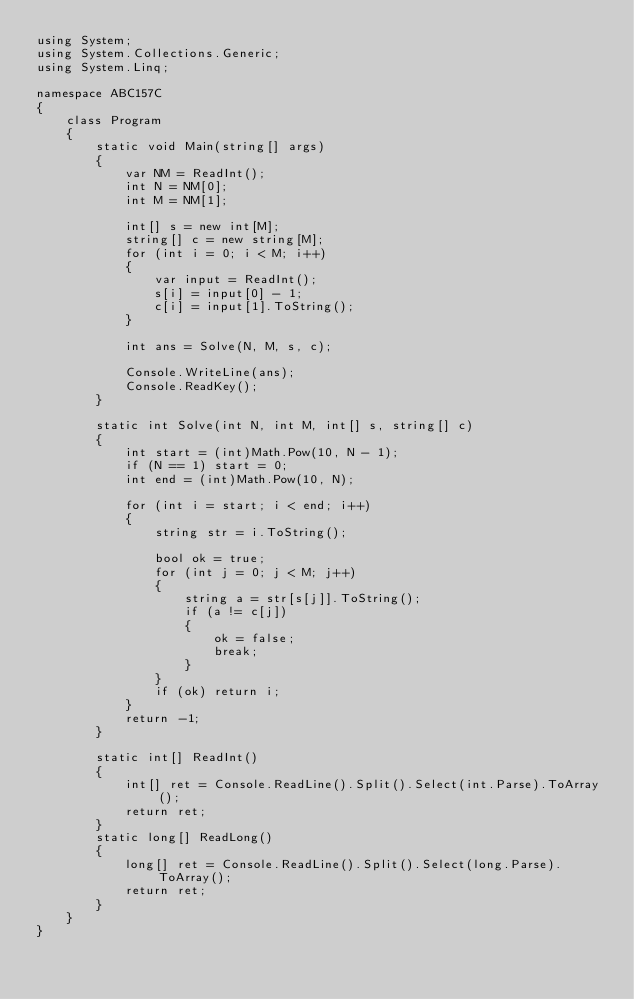Convert code to text. <code><loc_0><loc_0><loc_500><loc_500><_C#_>using System;
using System.Collections.Generic;
using System.Linq;

namespace ABC157C
{
    class Program
    {
        static void Main(string[] args)
        {
            var NM = ReadInt();
            int N = NM[0];
            int M = NM[1];

            int[] s = new int[M];
            string[] c = new string[M];
            for (int i = 0; i < M; i++)
            {
                var input = ReadInt();
                s[i] = input[0] - 1;
                c[i] = input[1].ToString();
            }

            int ans = Solve(N, M, s, c);

            Console.WriteLine(ans);
            Console.ReadKey();
        }

        static int Solve(int N, int M, int[] s, string[] c)
        {
            int start = (int)Math.Pow(10, N - 1);
            if (N == 1) start = 0;
            int end = (int)Math.Pow(10, N);

            for (int i = start; i < end; i++)
            {
                string str = i.ToString();

                bool ok = true;
                for (int j = 0; j < M; j++)
                {
                    string a = str[s[j]].ToString();
                    if (a != c[j])
                    {
                        ok = false;
                        break;
                    }
                }
                if (ok) return i;
            }
            return -1;
        }

        static int[] ReadInt()
        {
            int[] ret = Console.ReadLine().Split().Select(int.Parse).ToArray();
            return ret;
        }
        static long[] ReadLong()
        {
            long[] ret = Console.ReadLine().Split().Select(long.Parse).ToArray();
            return ret;
        }
    }
}
</code> 